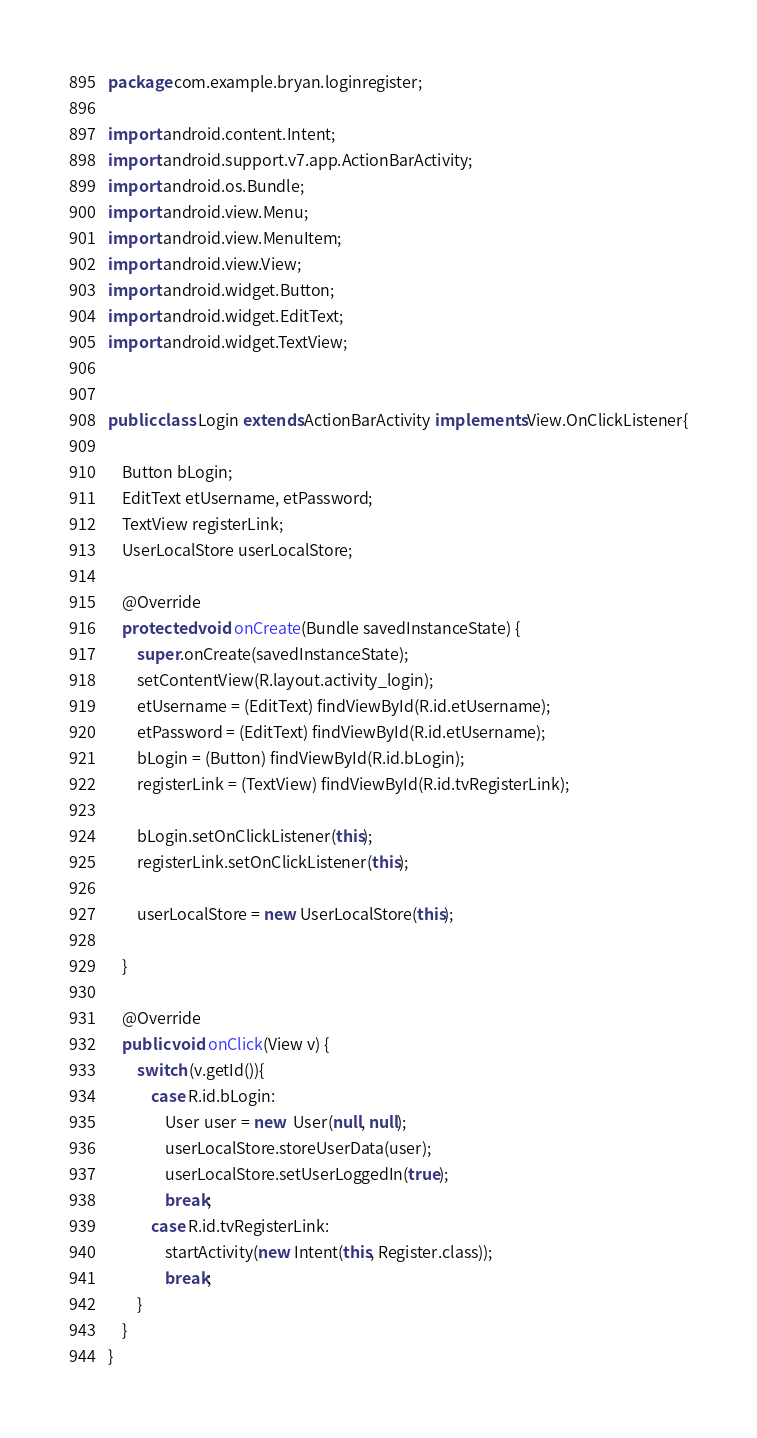<code> <loc_0><loc_0><loc_500><loc_500><_Java_>package com.example.bryan.loginregister;

import android.content.Intent;
import android.support.v7.app.ActionBarActivity;
import android.os.Bundle;
import android.view.Menu;
import android.view.MenuItem;
import android.view.View;
import android.widget.Button;
import android.widget.EditText;
import android.widget.TextView;


public class Login extends ActionBarActivity implements View.OnClickListener{

    Button bLogin;
    EditText etUsername, etPassword;
    TextView registerLink;
    UserLocalStore userLocalStore;

    @Override
    protected void onCreate(Bundle savedInstanceState) {
        super.onCreate(savedInstanceState);
        setContentView(R.layout.activity_login);
        etUsername = (EditText) findViewById(R.id.etUsername);
        etPassword = (EditText) findViewById(R.id.etUsername);
        bLogin = (Button) findViewById(R.id.bLogin);
        registerLink = (TextView) findViewById(R.id.tvRegisterLink);

        bLogin.setOnClickListener(this);
        registerLink.setOnClickListener(this);

        userLocalStore = new UserLocalStore(this);

    }

    @Override
    public void onClick(View v) {
        switch (v.getId()){
            case R.id.bLogin:
                User user = new  User(null, null);
                userLocalStore.storeUserData(user);
                userLocalStore.setUserLoggedIn(true);
                break;
            case R.id.tvRegisterLink:
                startActivity(new Intent(this, Register.class));
                break;
        }
    }
}
</code> 